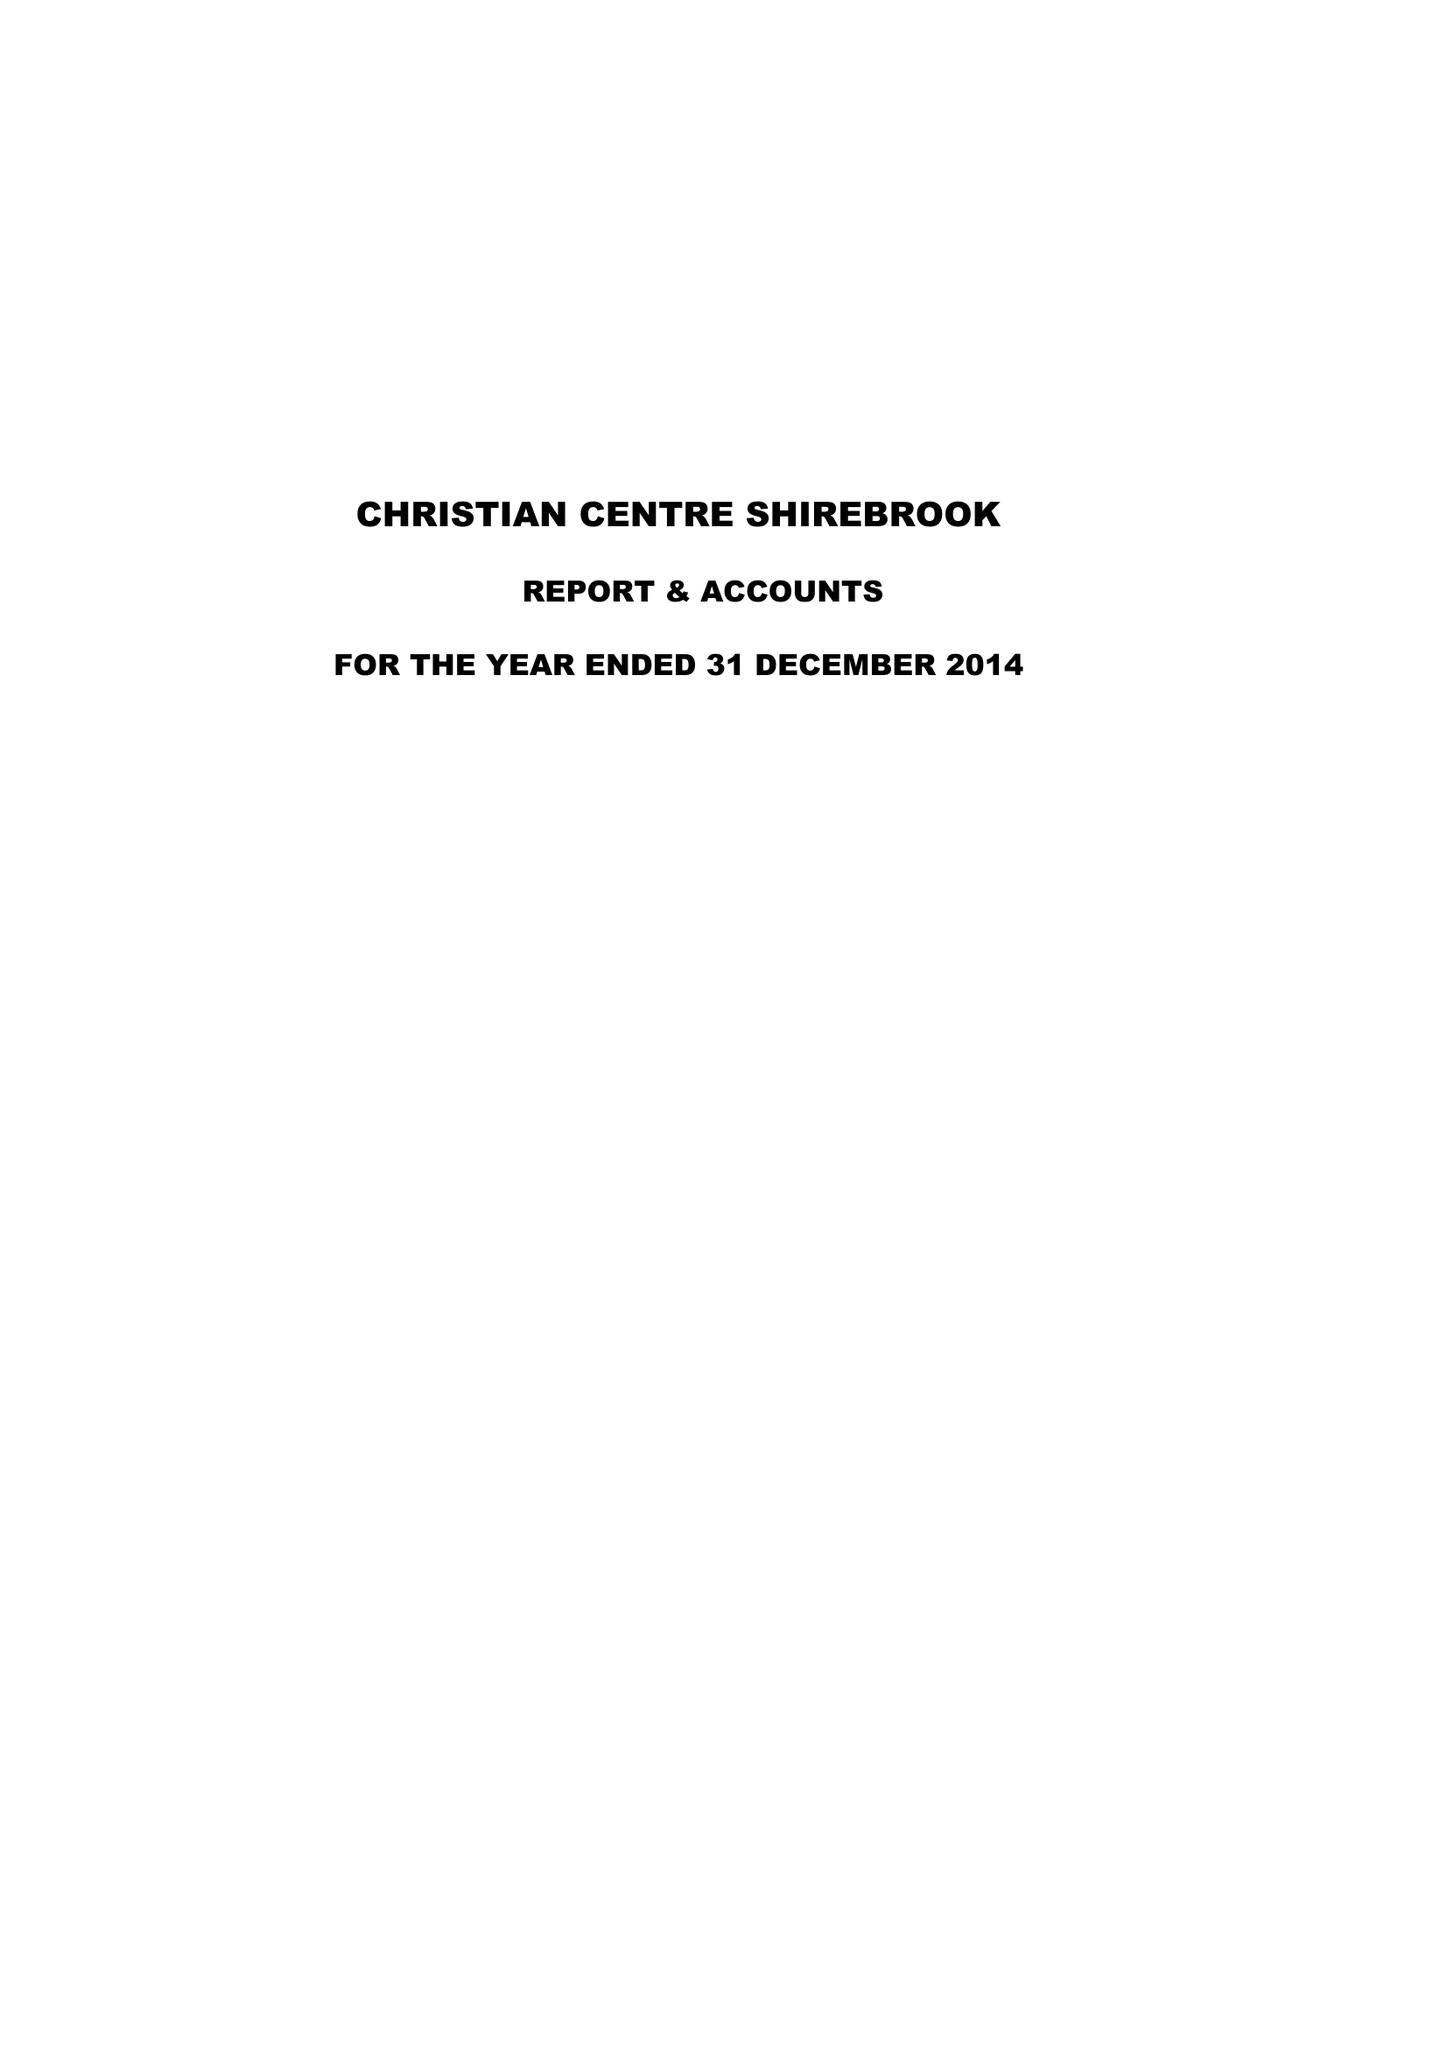What is the value for the charity_number?
Answer the question using a single word or phrase. 1052624 